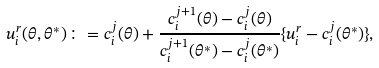<formula> <loc_0><loc_0><loc_500><loc_500>u _ { i } ^ { r } ( \theta , \theta ^ { * } ) \colon = c ^ { j } _ { i } ( \theta ) + \frac { c ^ { j + 1 } _ { i } ( \theta ) - c ^ { j } _ { i } ( \theta ) } { c ^ { j + 1 } _ { i } ( \theta ^ { * } ) - c ^ { j } _ { i } ( \theta ^ { * } ) } \{ u _ { i } ^ { r } - c ^ { j } _ { i } ( \theta ^ { * } ) \} ,</formula> 